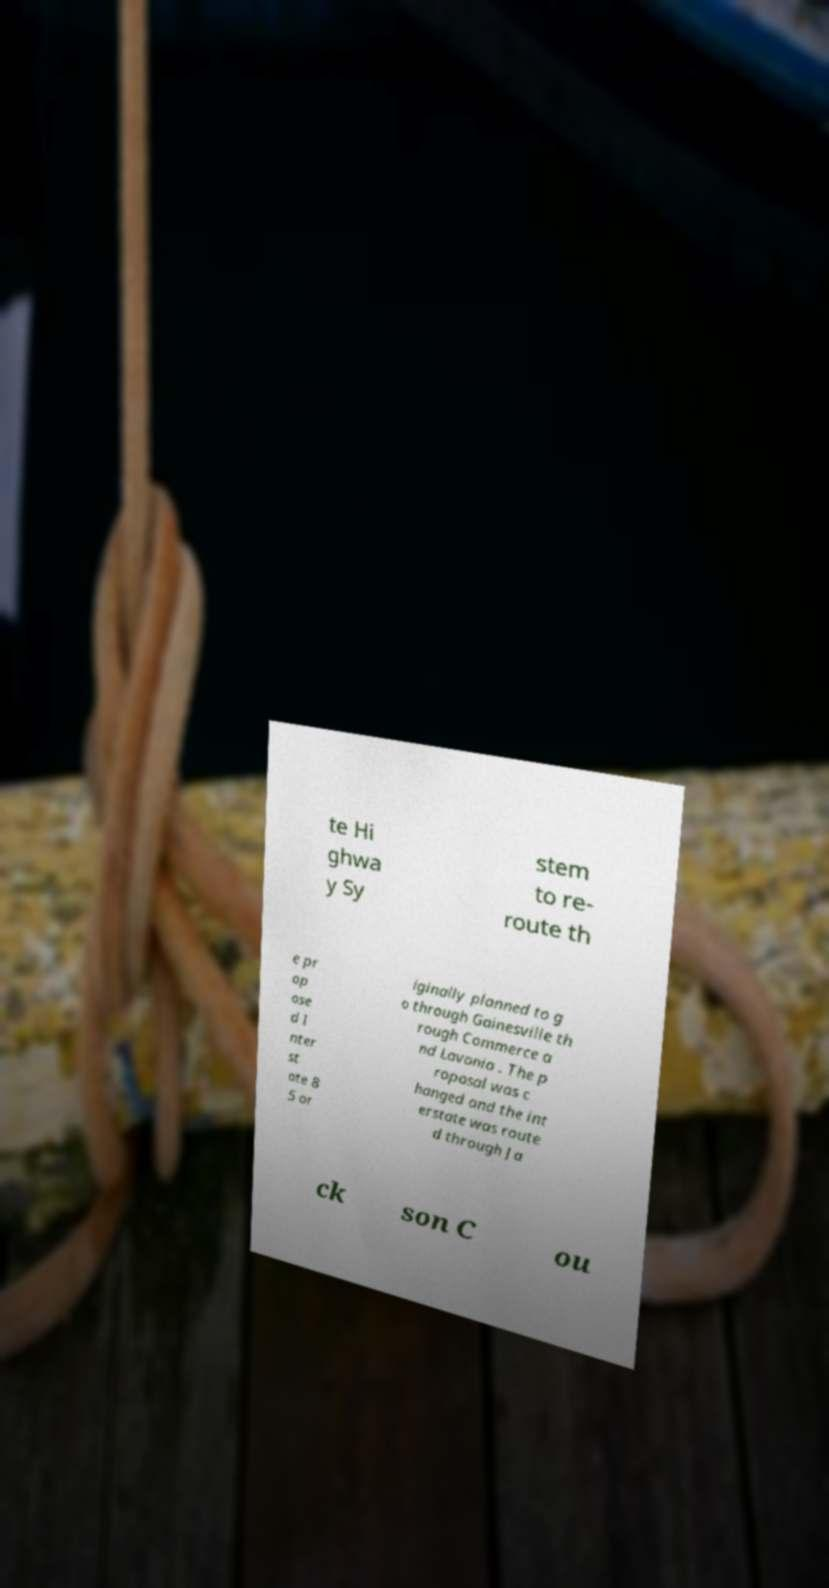There's text embedded in this image that I need extracted. Can you transcribe it verbatim? te Hi ghwa y Sy stem to re- route th e pr op ose d I nter st ate 8 5 or iginally planned to g o through Gainesville th rough Commerce a nd Lavonia . The p roposal was c hanged and the int erstate was route d through Ja ck son C ou 